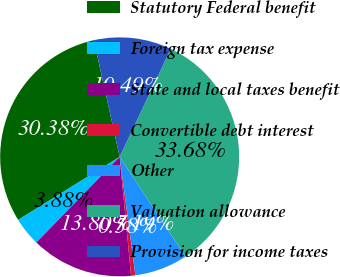Convert chart to OTSL. <chart><loc_0><loc_0><loc_500><loc_500><pie_chart><fcel>Statutory Federal benefit<fcel>Foreign tax expense<fcel>State and local taxes benefit<fcel>Convertible debt interest<fcel>Other<fcel>Valuation allowance<fcel>Provision for income taxes<nl><fcel>30.38%<fcel>3.88%<fcel>13.8%<fcel>0.58%<fcel>7.19%<fcel>33.68%<fcel>10.49%<nl></chart> 